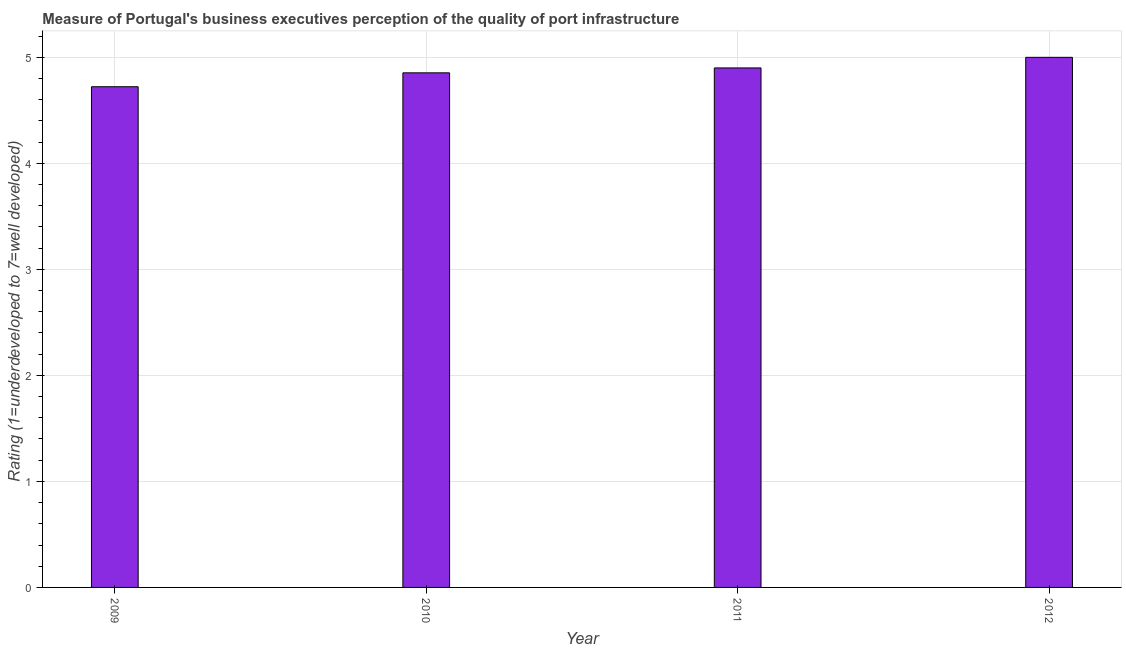What is the title of the graph?
Your answer should be very brief. Measure of Portugal's business executives perception of the quality of port infrastructure. What is the label or title of the Y-axis?
Make the answer very short. Rating (1=underdeveloped to 7=well developed) . What is the rating measuring quality of port infrastructure in 2010?
Offer a very short reply. 4.85. Across all years, what is the maximum rating measuring quality of port infrastructure?
Offer a very short reply. 5. Across all years, what is the minimum rating measuring quality of port infrastructure?
Your answer should be compact. 4.72. In which year was the rating measuring quality of port infrastructure minimum?
Your answer should be very brief. 2009. What is the sum of the rating measuring quality of port infrastructure?
Offer a very short reply. 19.48. What is the difference between the rating measuring quality of port infrastructure in 2009 and 2011?
Your response must be concise. -0.18. What is the average rating measuring quality of port infrastructure per year?
Keep it short and to the point. 4.87. What is the median rating measuring quality of port infrastructure?
Give a very brief answer. 4.88. Do a majority of the years between 2009 and 2012 (inclusive) have rating measuring quality of port infrastructure greater than 1 ?
Provide a short and direct response. Yes. What is the ratio of the rating measuring quality of port infrastructure in 2009 to that in 2010?
Give a very brief answer. 0.97. Is the difference between the rating measuring quality of port infrastructure in 2011 and 2012 greater than the difference between any two years?
Your response must be concise. No. Is the sum of the rating measuring quality of port infrastructure in 2009 and 2011 greater than the maximum rating measuring quality of port infrastructure across all years?
Provide a succinct answer. Yes. What is the difference between the highest and the lowest rating measuring quality of port infrastructure?
Offer a terse response. 0.28. In how many years, is the rating measuring quality of port infrastructure greater than the average rating measuring quality of port infrastructure taken over all years?
Your response must be concise. 2. How many bars are there?
Offer a terse response. 4. Are all the bars in the graph horizontal?
Give a very brief answer. No. What is the difference between two consecutive major ticks on the Y-axis?
Offer a terse response. 1. Are the values on the major ticks of Y-axis written in scientific E-notation?
Provide a succinct answer. No. What is the Rating (1=underdeveloped to 7=well developed)  of 2009?
Your answer should be very brief. 4.72. What is the Rating (1=underdeveloped to 7=well developed)  of 2010?
Provide a succinct answer. 4.85. What is the difference between the Rating (1=underdeveloped to 7=well developed)  in 2009 and 2010?
Make the answer very short. -0.13. What is the difference between the Rating (1=underdeveloped to 7=well developed)  in 2009 and 2011?
Keep it short and to the point. -0.18. What is the difference between the Rating (1=underdeveloped to 7=well developed)  in 2009 and 2012?
Your answer should be compact. -0.28. What is the difference between the Rating (1=underdeveloped to 7=well developed)  in 2010 and 2011?
Make the answer very short. -0.05. What is the difference between the Rating (1=underdeveloped to 7=well developed)  in 2010 and 2012?
Your response must be concise. -0.15. What is the ratio of the Rating (1=underdeveloped to 7=well developed)  in 2009 to that in 2010?
Your answer should be compact. 0.97. What is the ratio of the Rating (1=underdeveloped to 7=well developed)  in 2009 to that in 2011?
Give a very brief answer. 0.96. What is the ratio of the Rating (1=underdeveloped to 7=well developed)  in 2009 to that in 2012?
Provide a short and direct response. 0.94. What is the ratio of the Rating (1=underdeveloped to 7=well developed)  in 2010 to that in 2011?
Offer a terse response. 0.99. What is the ratio of the Rating (1=underdeveloped to 7=well developed)  in 2011 to that in 2012?
Offer a terse response. 0.98. 